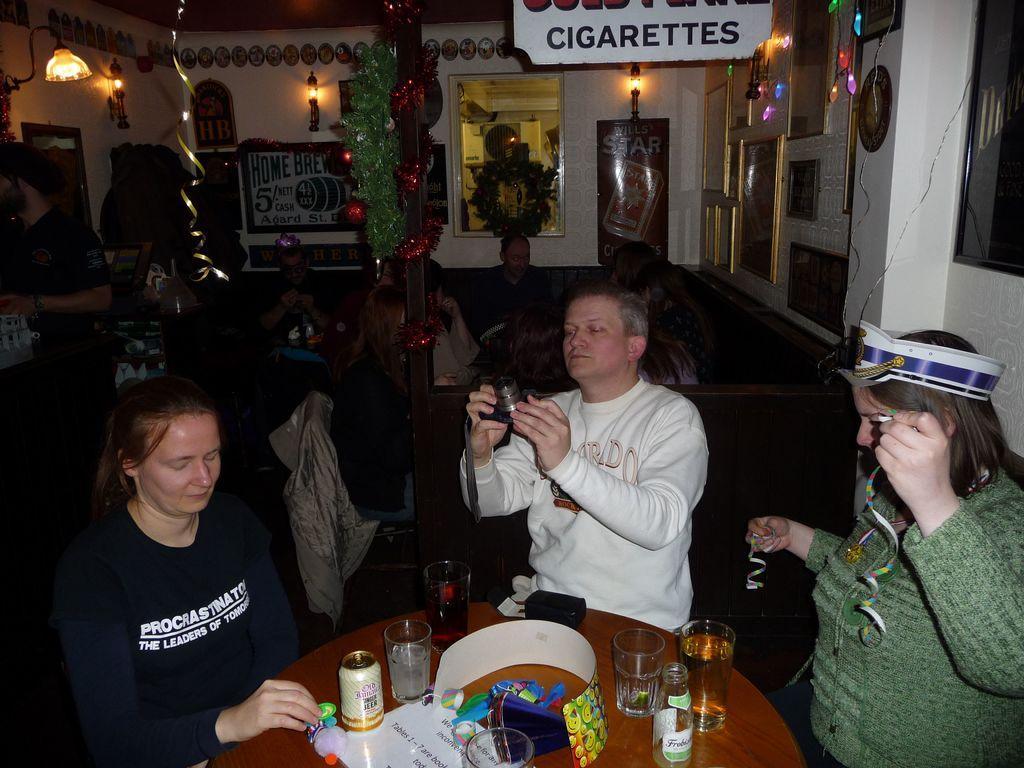Please provide a concise description of this image. Front this three persons are sitting on a chair, in-front of them there is a table, on this table there are glasses, bottle, things and tin. This man is holding a camera. Light is attached to wall. Poster and mirror is on wall. These are pictures on wall. To this pillar there are decorative items. These persons are also sitting on chairs. This man is standing. 